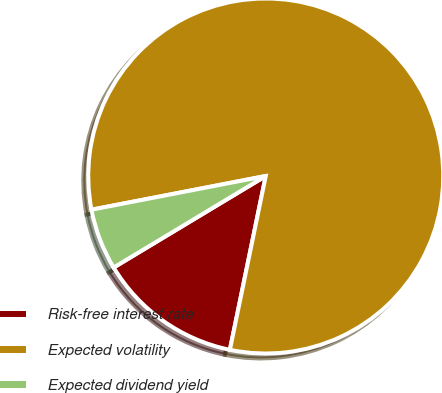<chart> <loc_0><loc_0><loc_500><loc_500><pie_chart><fcel>Risk-free interest rate<fcel>Expected volatility<fcel>Expected dividend yield<nl><fcel>13.14%<fcel>81.28%<fcel>5.58%<nl></chart> 